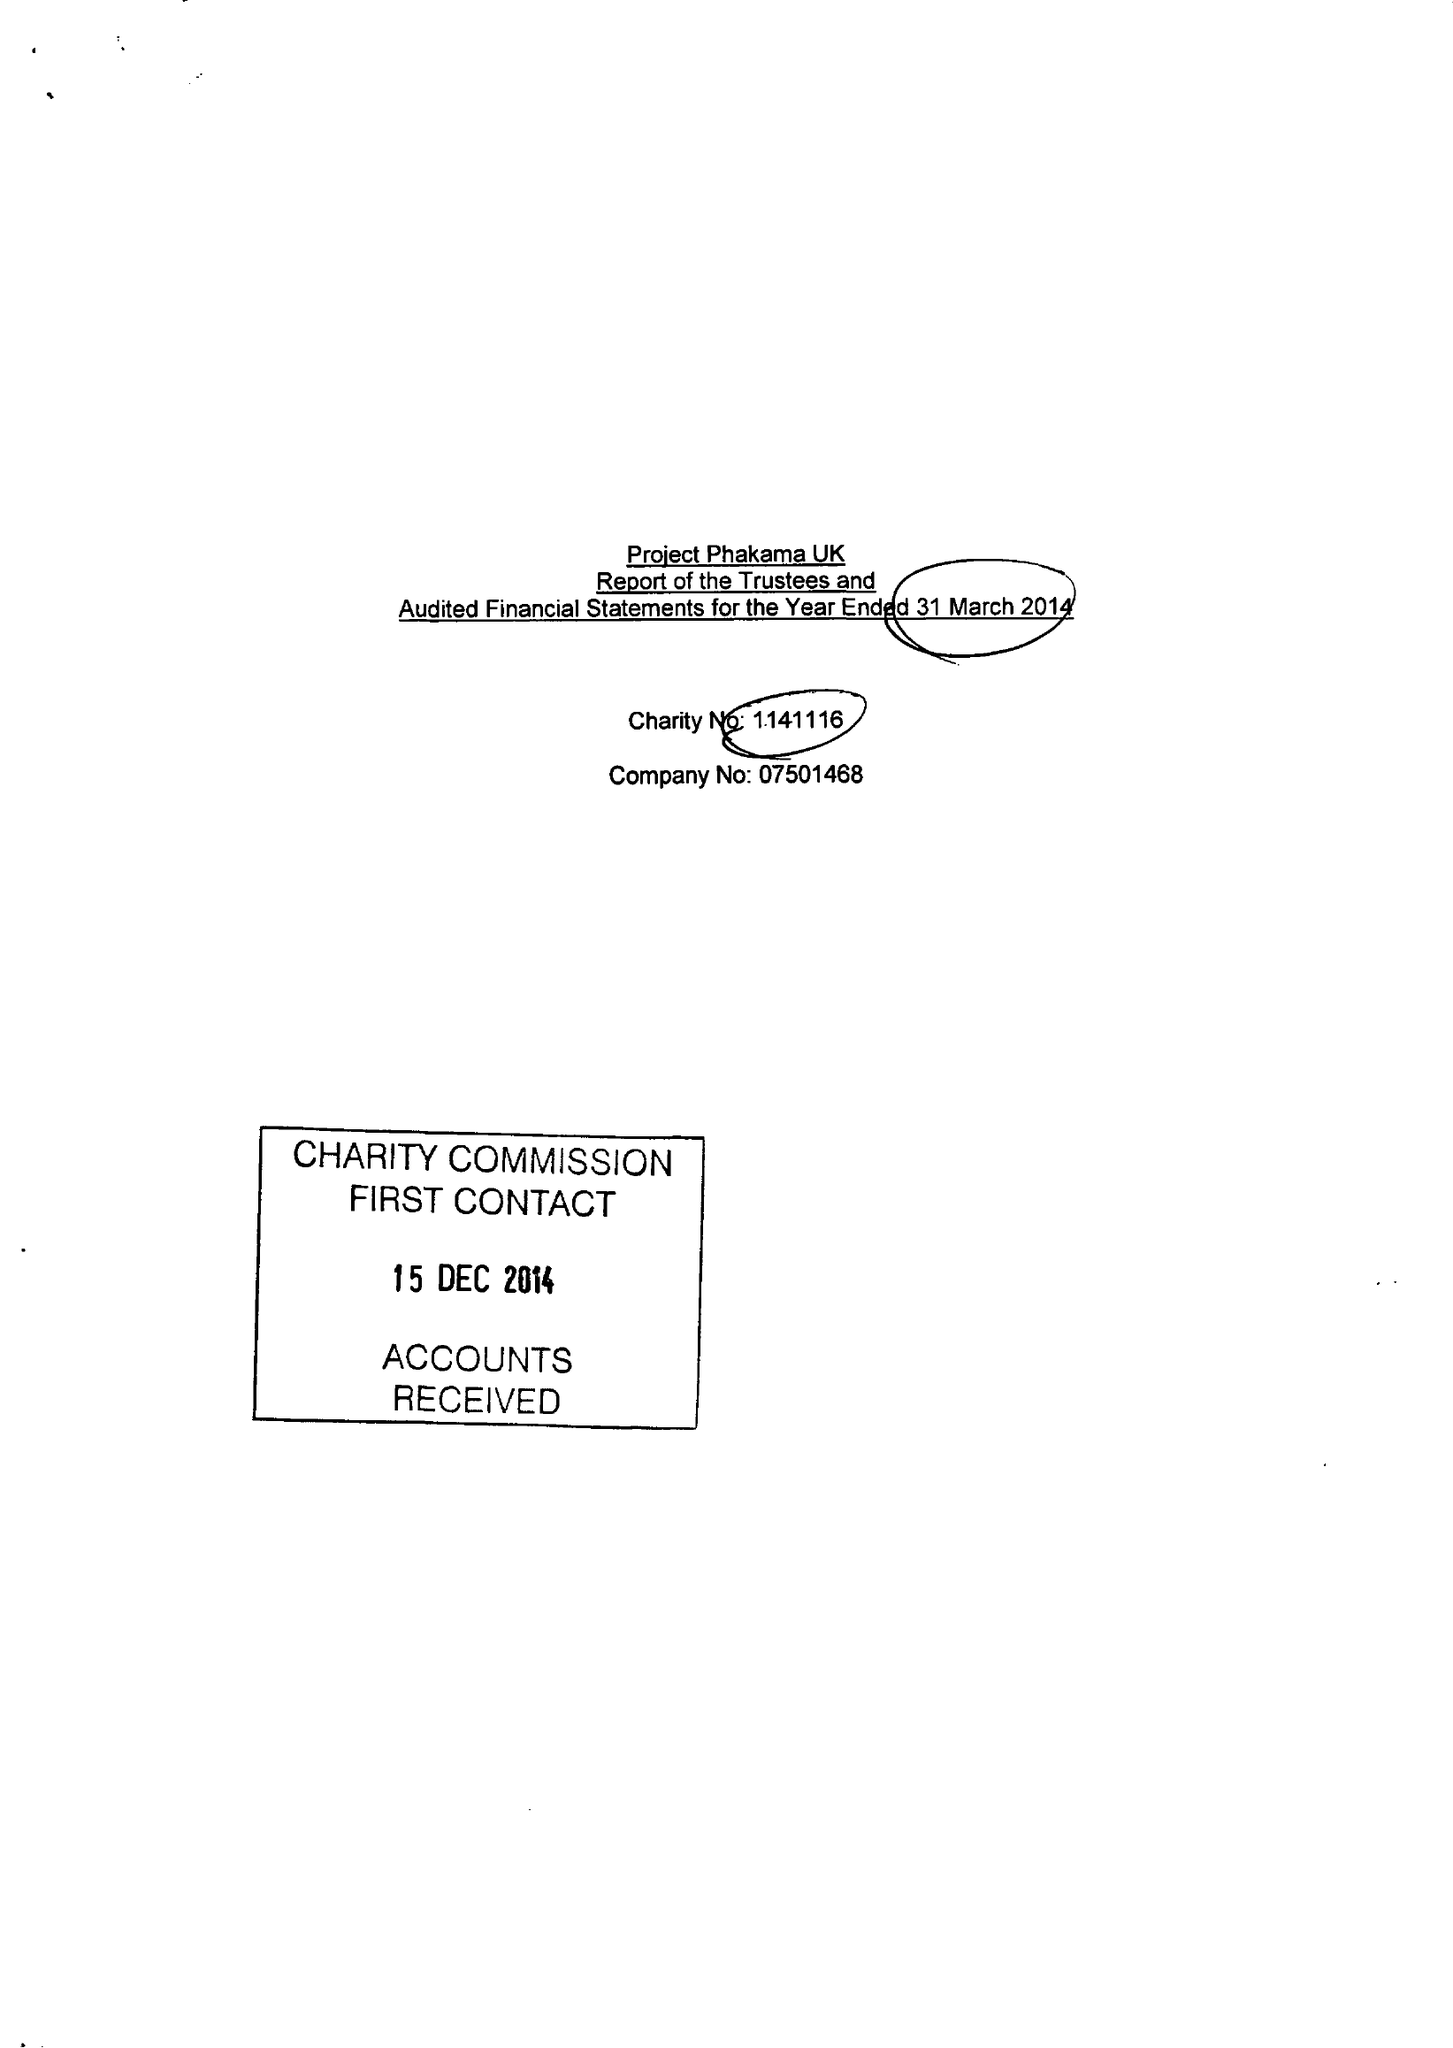What is the value for the report_date?
Answer the question using a single word or phrase. 2014-03-31 